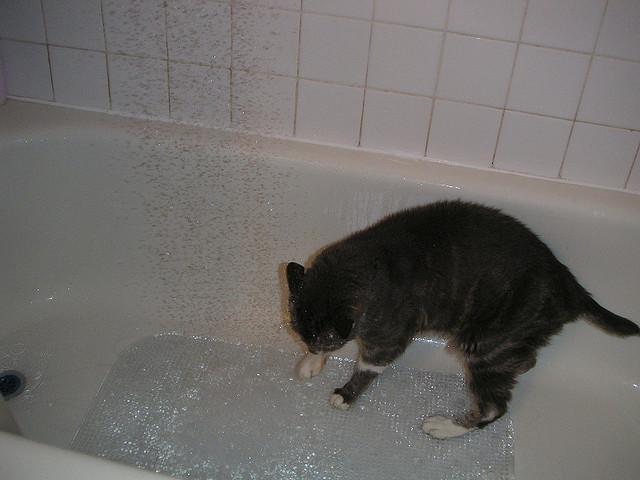How many boats are in the water?
Give a very brief answer. 0. 